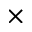<formula> <loc_0><loc_0><loc_500><loc_500>\times</formula> 